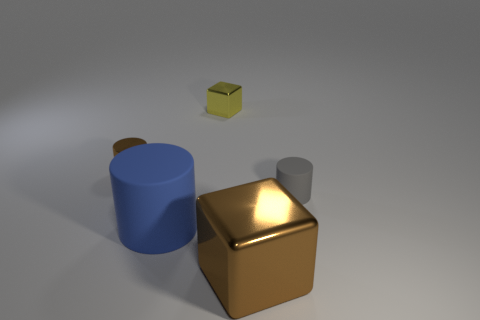The cylinder that is made of the same material as the big cube is what color? It appears that there are no cylinders made of the same material as the big cube visible in this image. The cube in the image is a golden color, and the only cylinder present is blue and seems to be made of a different material. 